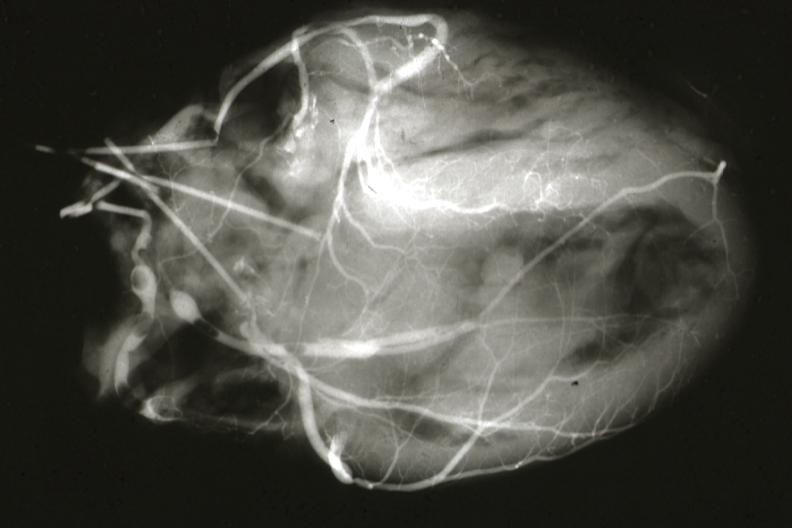what is present?
Answer the question using a single word or phrase. Myocardial infarct 